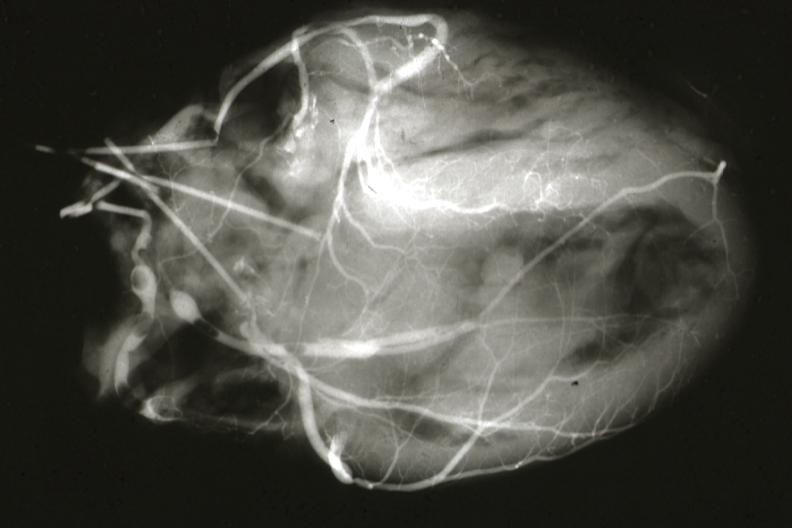what is present?
Answer the question using a single word or phrase. Myocardial infarct 